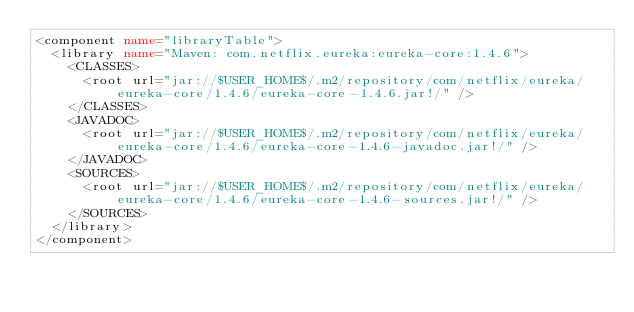Convert code to text. <code><loc_0><loc_0><loc_500><loc_500><_XML_><component name="libraryTable">
  <library name="Maven: com.netflix.eureka:eureka-core:1.4.6">
    <CLASSES>
      <root url="jar://$USER_HOME$/.m2/repository/com/netflix/eureka/eureka-core/1.4.6/eureka-core-1.4.6.jar!/" />
    </CLASSES>
    <JAVADOC>
      <root url="jar://$USER_HOME$/.m2/repository/com/netflix/eureka/eureka-core/1.4.6/eureka-core-1.4.6-javadoc.jar!/" />
    </JAVADOC>
    <SOURCES>
      <root url="jar://$USER_HOME$/.m2/repository/com/netflix/eureka/eureka-core/1.4.6/eureka-core-1.4.6-sources.jar!/" />
    </SOURCES>
  </library>
</component></code> 